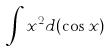<formula> <loc_0><loc_0><loc_500><loc_500>\int x ^ { 2 } d ( \cos x )</formula> 